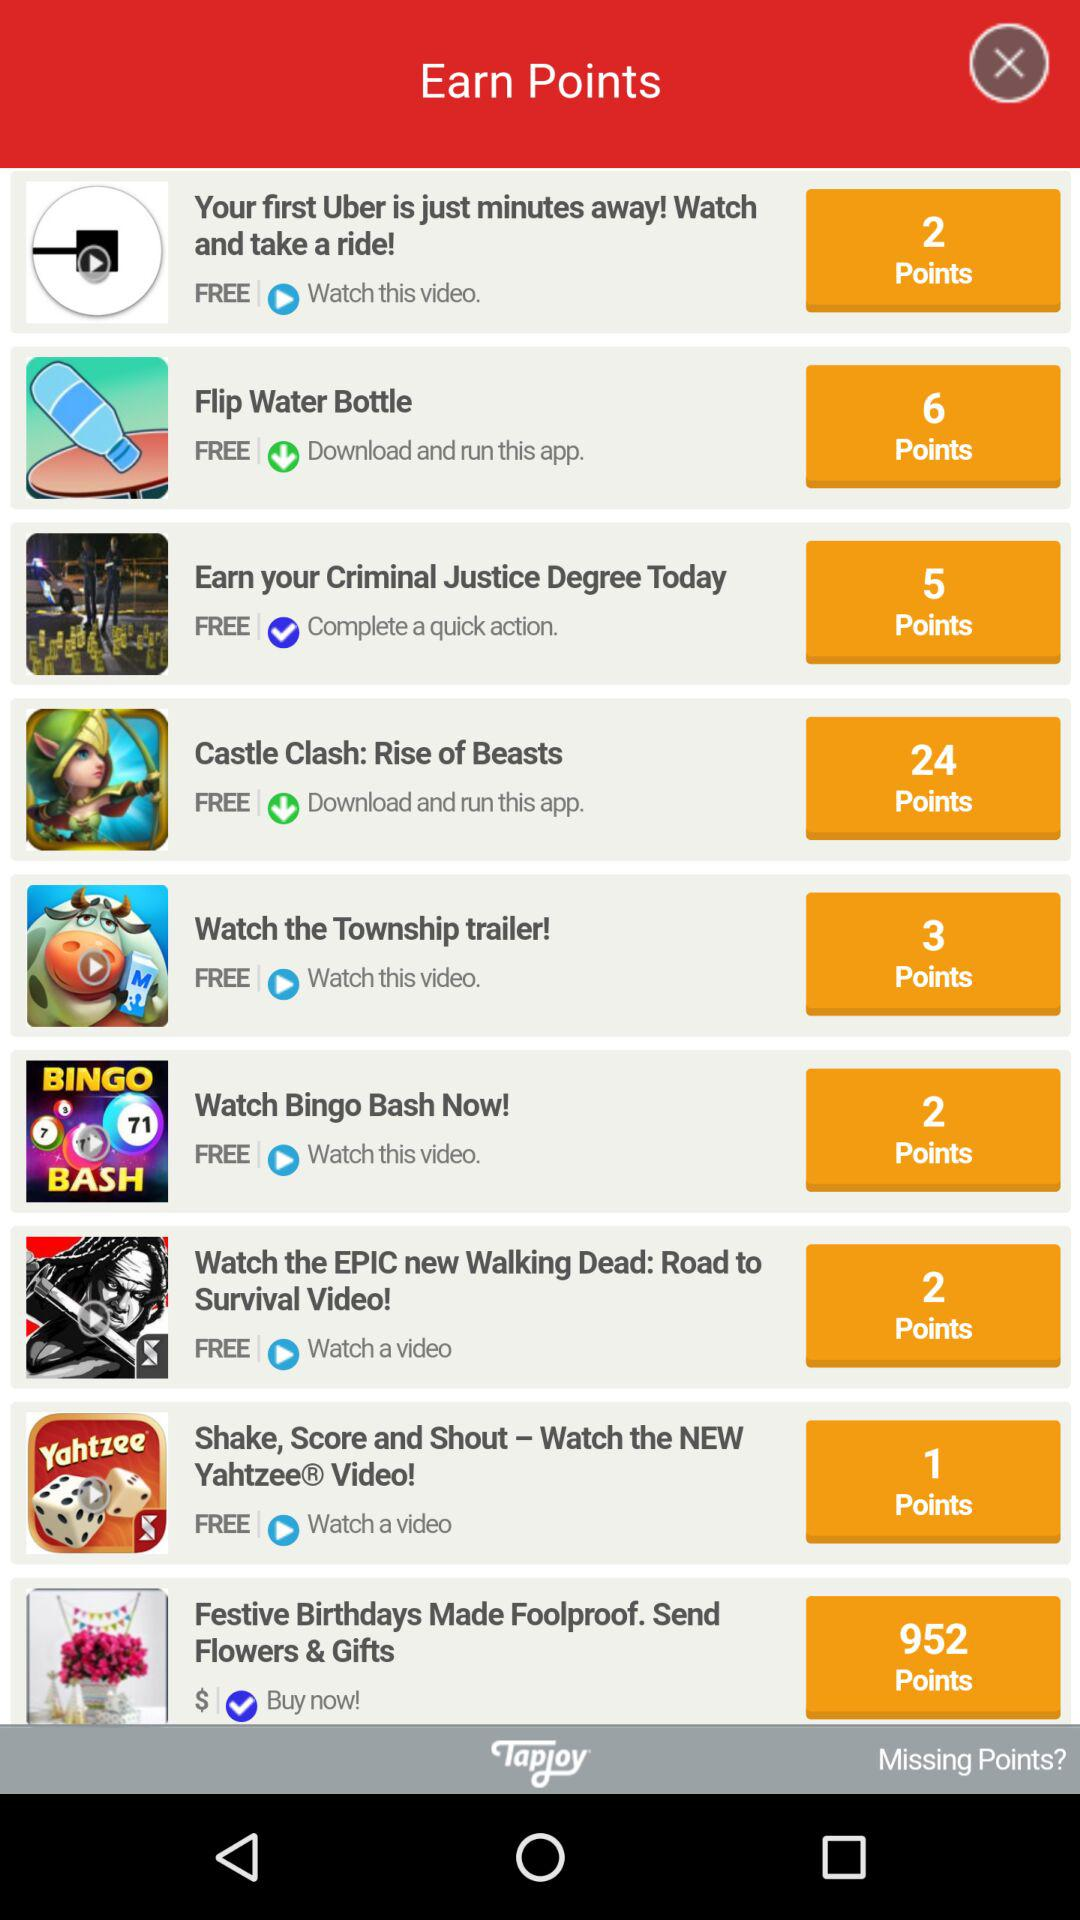How many points can be earned if "Castle Clash: Rise of Beasts" is downloaded? The points that can be earned are 24. 